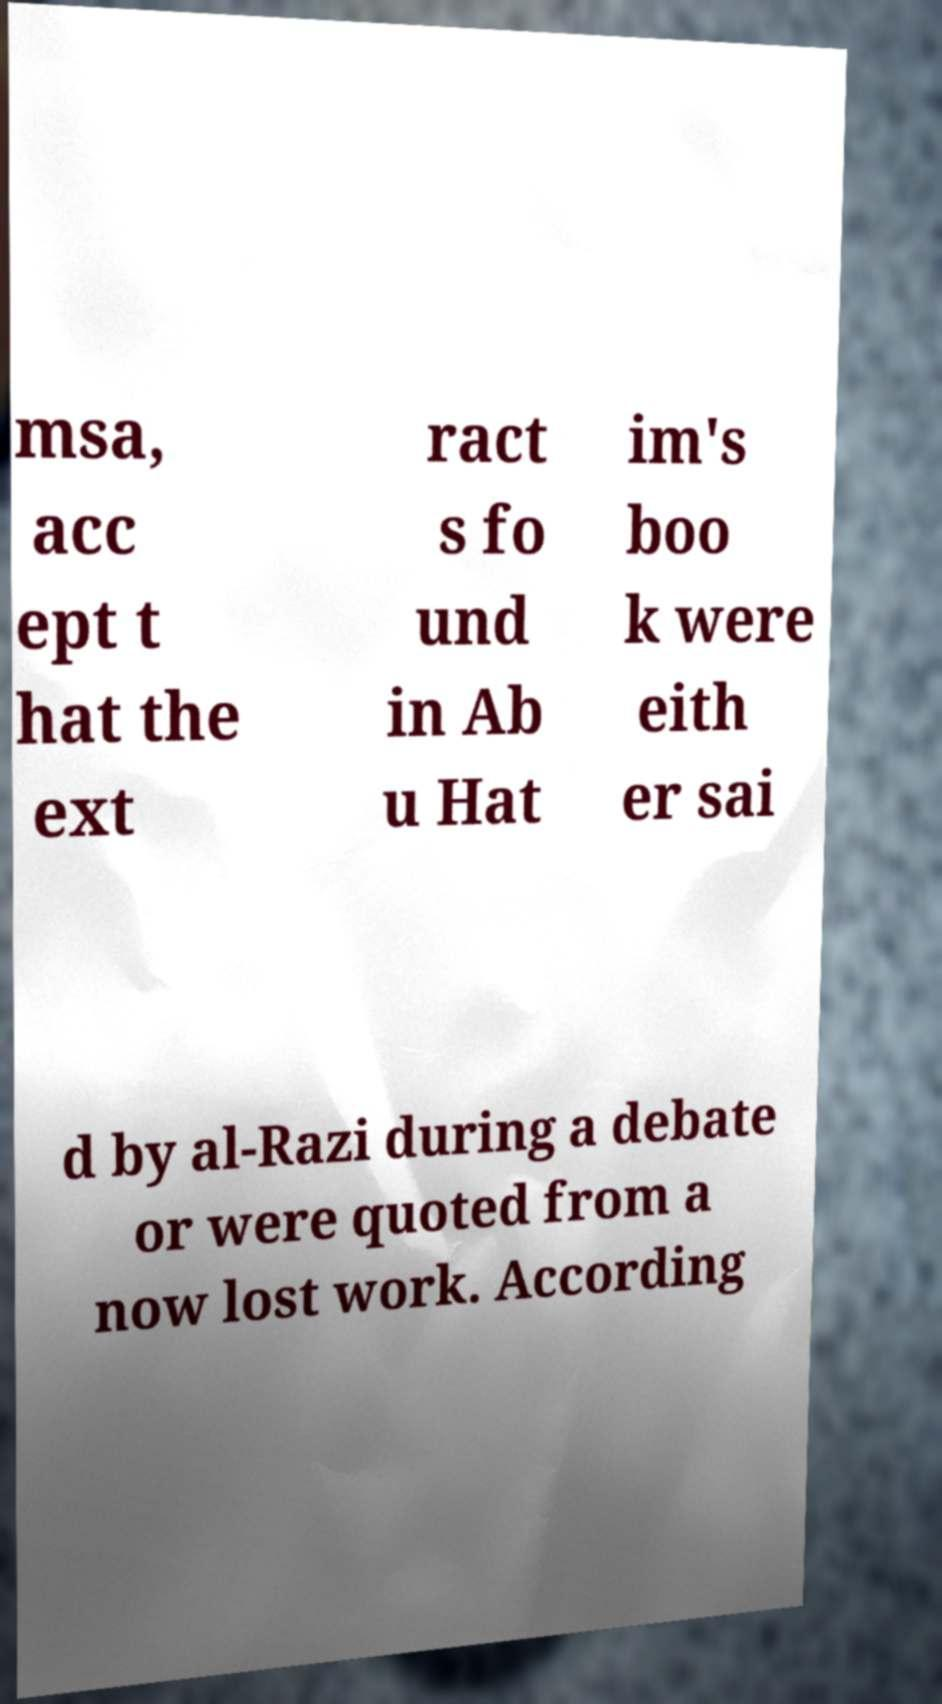What messages or text are displayed in this image? I need them in a readable, typed format. msa, acc ept t hat the ext ract s fo und in Ab u Hat im's boo k were eith er sai d by al-Razi during a debate or were quoted from a now lost work. According 